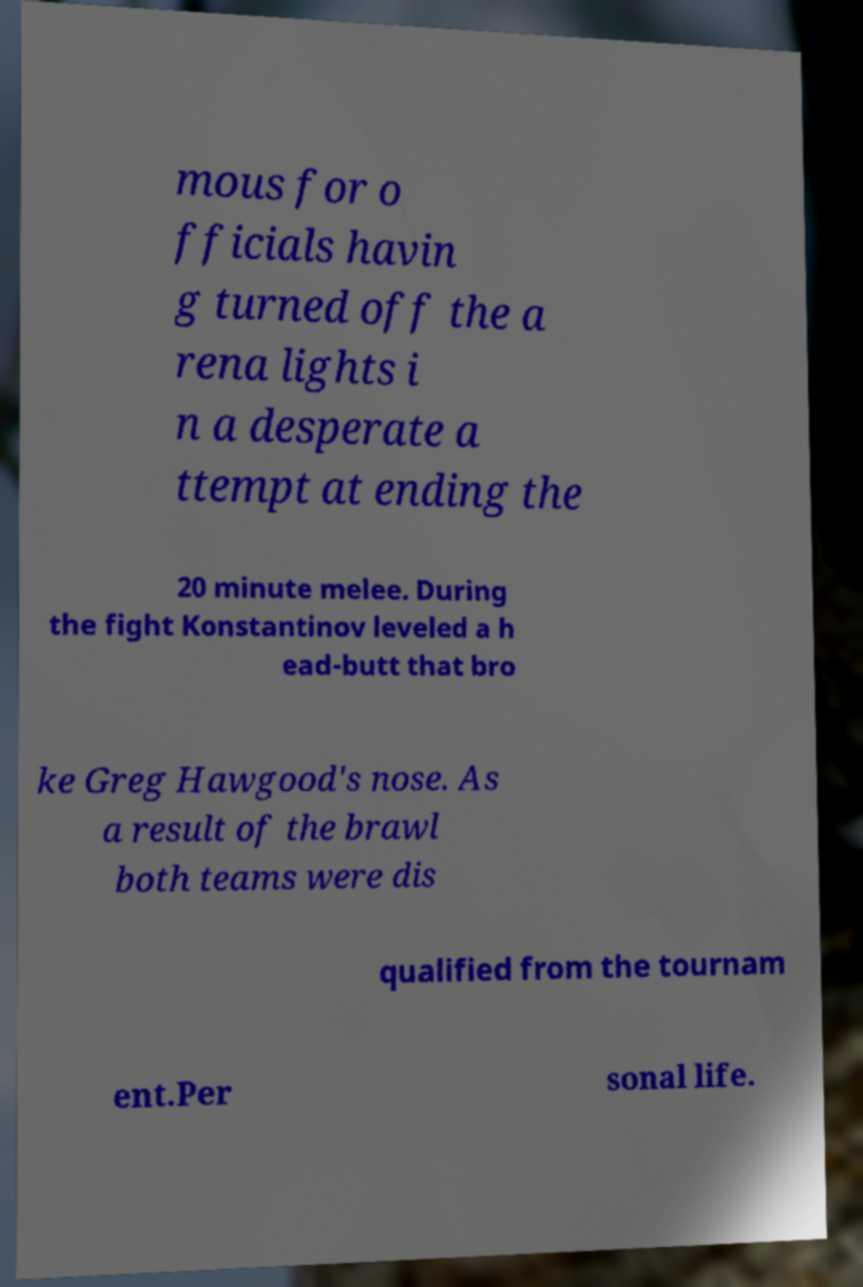There's text embedded in this image that I need extracted. Can you transcribe it verbatim? mous for o fficials havin g turned off the a rena lights i n a desperate a ttempt at ending the 20 minute melee. During the fight Konstantinov leveled a h ead-butt that bro ke Greg Hawgood's nose. As a result of the brawl both teams were dis qualified from the tournam ent.Per sonal life. 